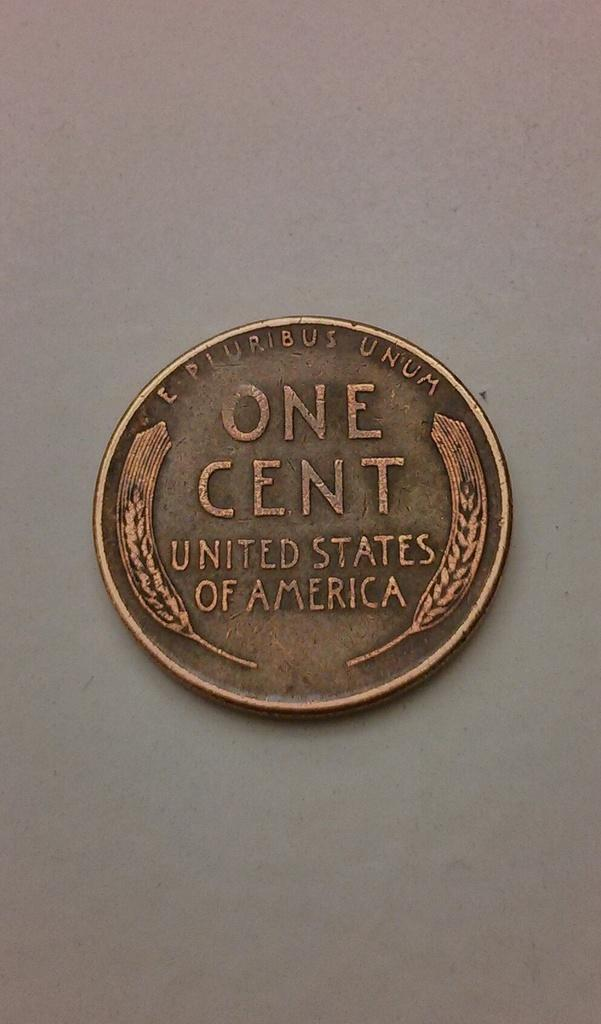<image>
Summarize the visual content of the image. One cent coin from the United States of America on top of a surface. 